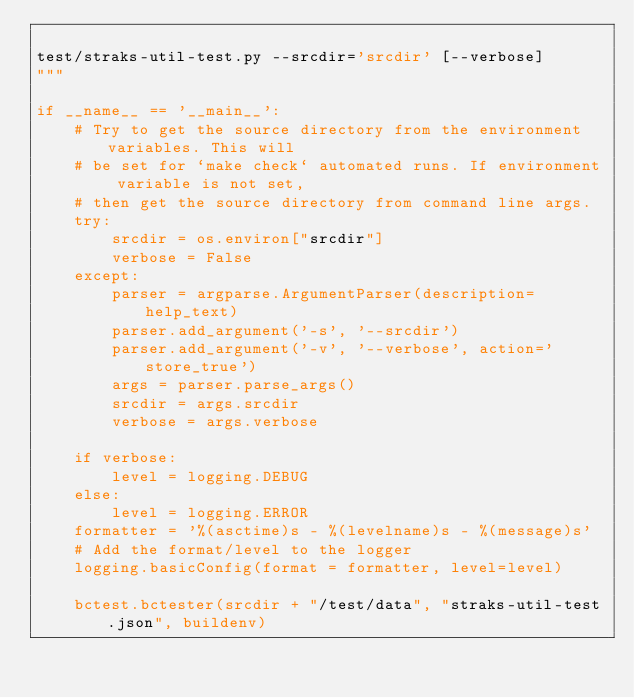<code> <loc_0><loc_0><loc_500><loc_500><_Python_>
test/straks-util-test.py --srcdir='srcdir' [--verbose]
"""

if __name__ == '__main__':
    # Try to get the source directory from the environment variables. This will
    # be set for `make check` automated runs. If environment variable is not set,
    # then get the source directory from command line args.
    try:
        srcdir = os.environ["srcdir"]
        verbose = False
    except:
        parser = argparse.ArgumentParser(description=help_text)
        parser.add_argument('-s', '--srcdir')
        parser.add_argument('-v', '--verbose', action='store_true')
        args = parser.parse_args()
        srcdir = args.srcdir
        verbose = args.verbose

    if verbose:
        level = logging.DEBUG
    else:
        level = logging.ERROR
    formatter = '%(asctime)s - %(levelname)s - %(message)s'
    # Add the format/level to the logger
    logging.basicConfig(format = formatter, level=level)

    bctest.bctester(srcdir + "/test/data", "straks-util-test.json", buildenv)
</code> 